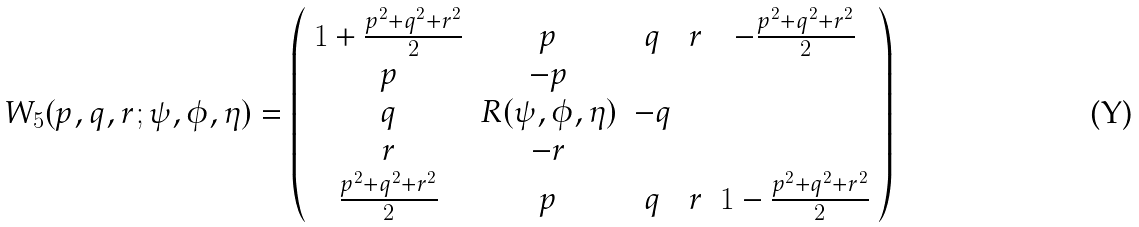<formula> <loc_0><loc_0><loc_500><loc_500>W _ { 5 } ( p , q , r ; \psi , \phi , \eta ) = \left ( \begin{array} { c c c c c } { { 1 + \frac { p ^ { 2 } + q ^ { 2 } + r ^ { 2 } } { 2 } } } & { p } & { q } & { r } & { { - \frac { p ^ { 2 } + q ^ { 2 } + r ^ { 2 } } { 2 } } } \\ { p } & { - p } \\ { q } & { R ( \psi , \phi , \eta ) } & { - q } \\ { r } & { - r } \\ { { \frac { p ^ { 2 } + q ^ { 2 } + r ^ { 2 } } { 2 } } } & { p } & { q } & { r } & { { 1 - \frac { p ^ { 2 } + q ^ { 2 } + r ^ { 2 } } { 2 } } } \end{array} \right )</formula> 